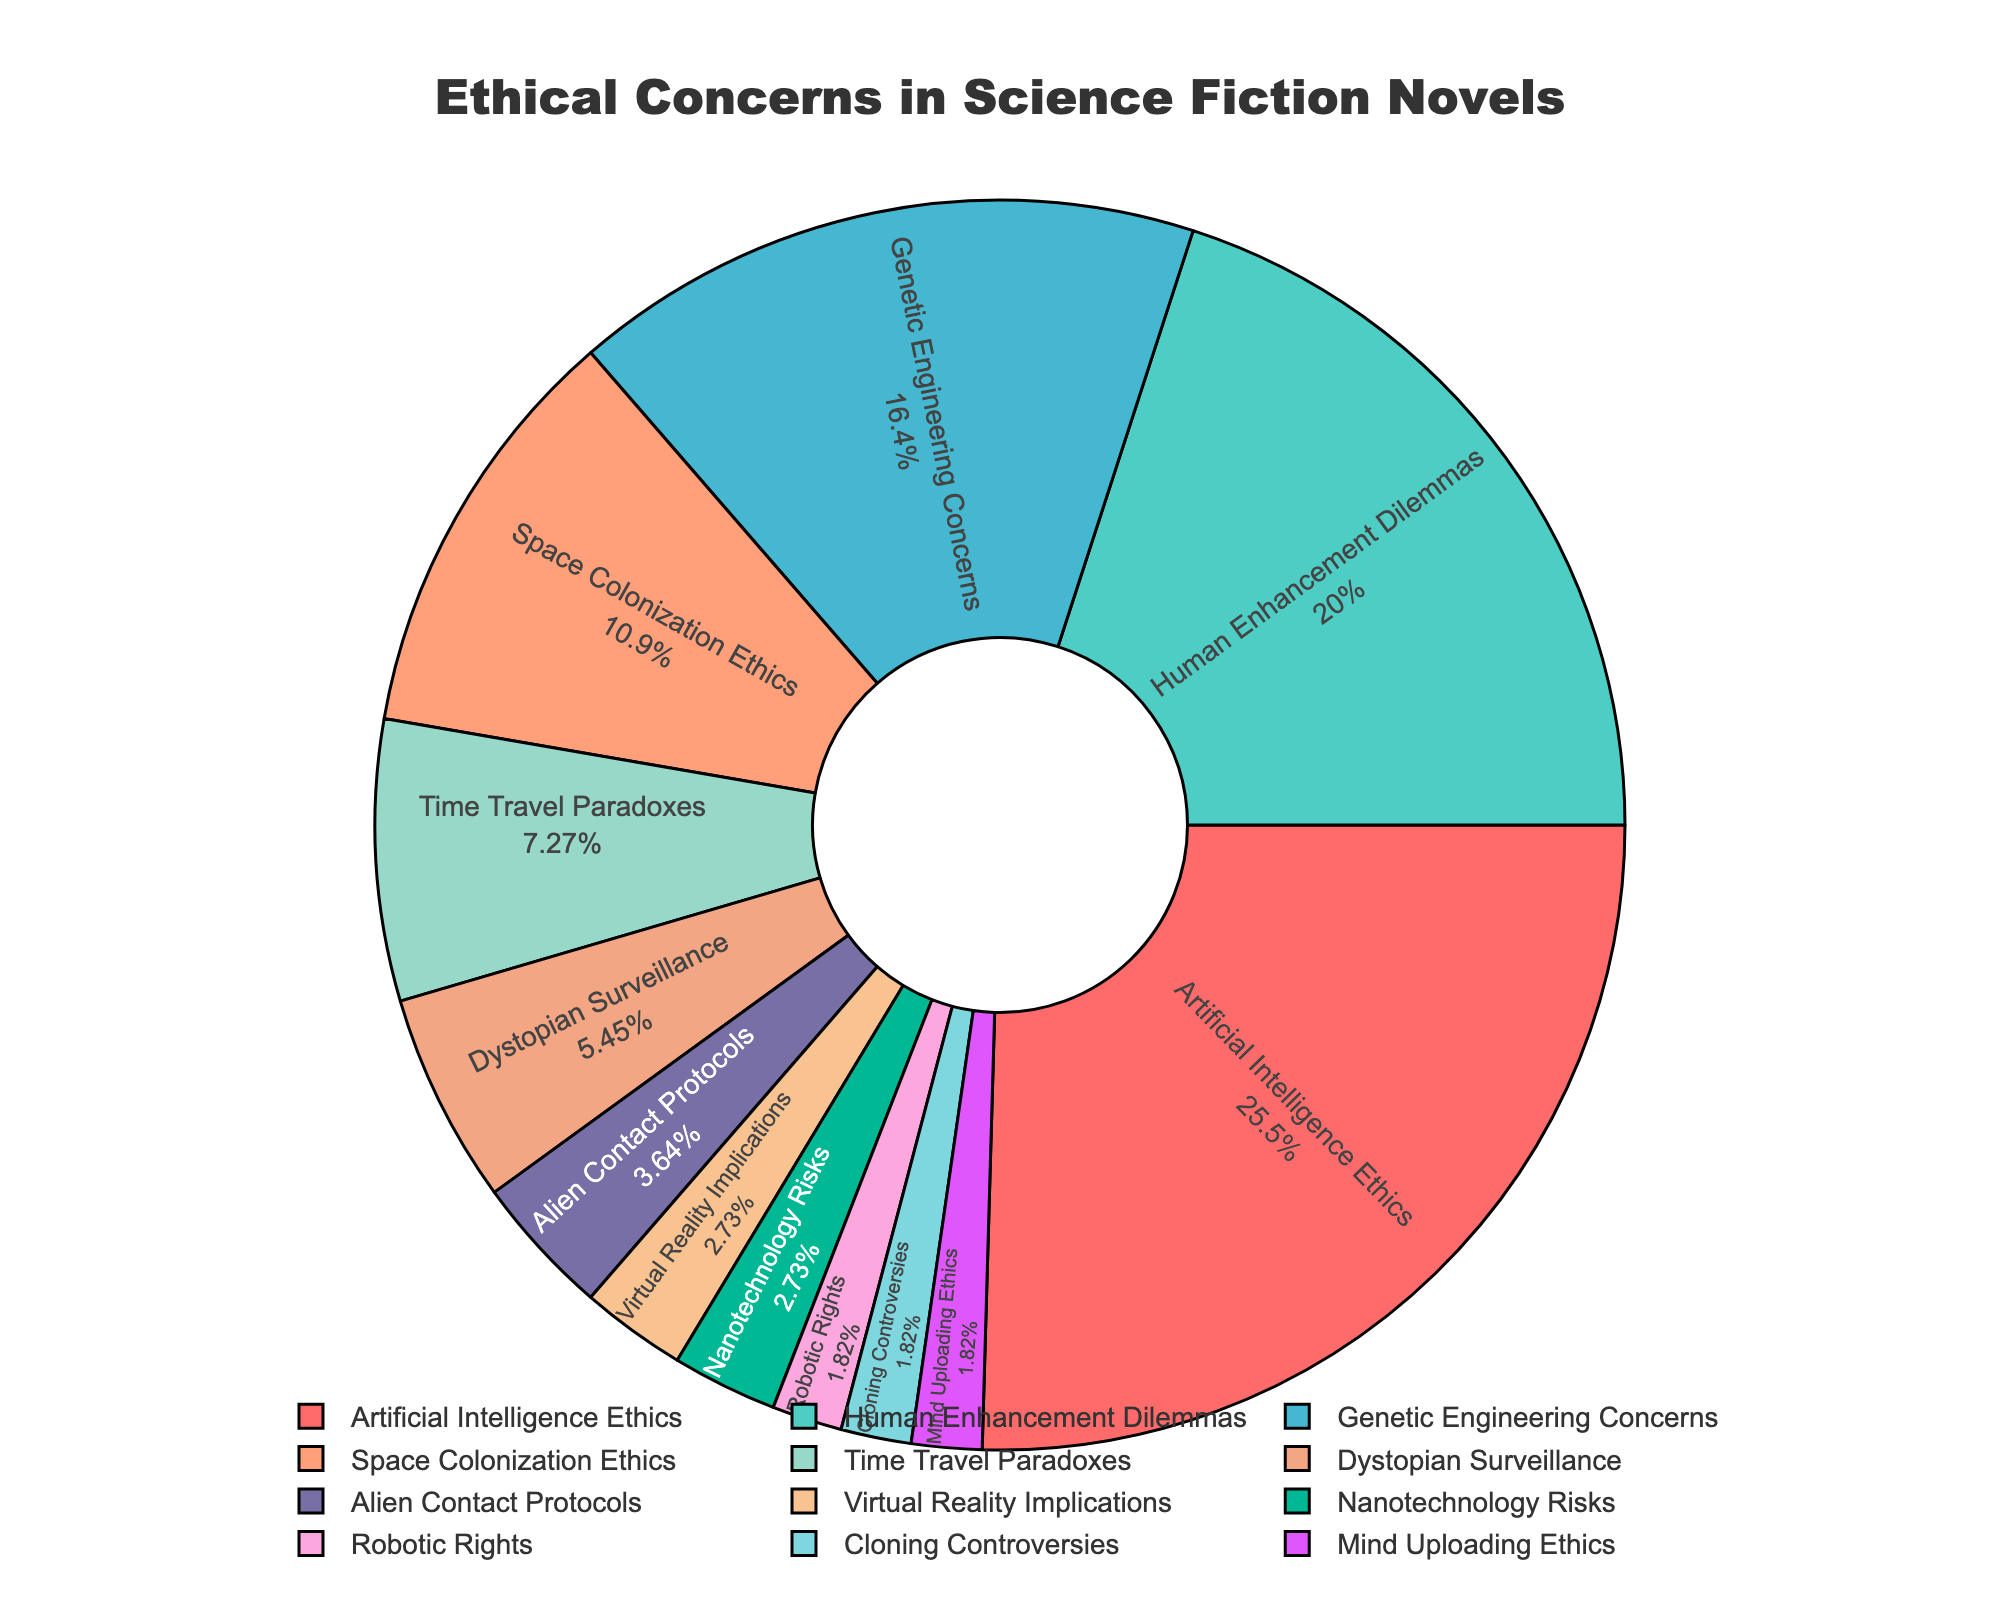Which category has the largest percentage of ethical concerns? By examining the chart, the largest segment is labeled "Artificial Intelligence Ethics" with a percentage of 28%.
Answer: Artificial Intelligence Ethics Which category has the smallest percentage of ethical concerns? By examining the chart, the smallest segments are labeled "Robotic Rights," "Cloning Controversies," and "Mind Uploading Ethics," each with a percentage of 2%.
Answer: Robotic Rights, Cloning Controversies, Mind Uploading Ethics What is the combined percentage of ethical concerns for "Human Enhancement Dilemmas" and "Genetic Engineering Concerns"? Adding the percentages of "Human Enhancement Dilemmas" (22%) and "Genetic Engineering Concerns" (18%) yields 22% + 18% = 40%.
Answer: 40% How does the percentage of "Space Colonization Ethics" compare to "Time Travel Paradoxes"? "Space Colonization Ethics" has a percentage of 12%, while "Time Travel Paradoxes" has a percentage of 8%. Hence, "Space Colonization Ethics" has a higher percentage.
Answer: Space Colonization Ethics > Time Travel Paradoxes What is the percentage difference between "Dystopian Surveillance" and "Virtual Reality Implications"? "Dystopian Surveillance" has 6%, while "Virtual Reality Implications" has 3%. The difference is 6% - 3% = 3%.
Answer: 3% Which color is associated with the largest segment, and what is the ethical concern? The largest segment, representing "Artificial Intelligence Ethics," is colored red as per the color palette described.
Answer: Red, Artificial Intelligence Ethics What is the total percentage of all categories related to robotics (including "Artificial Intelligence Ethics" and "Robotic Rights")? The percentages are 28% for "Artificial Intelligence Ethics" and 2% for "Robotic Rights". Adding them gives 28% + 2% = 30%.
Answer: 30% How many categories have a percentage of 10% or higher? Categories with 10% or higher are "Artificial Intelligence Ethics" (28%), "Human Enhancement Dilemmas" (22%), "Genetic Engineering Concerns" (18%), and "Space Colonization Ethics" (12%). There are 4 such categories.
Answer: 4 Does the category "Nanotechnology Risks" have a higher or lower percentage than "Alien Contact Protocols"? "Nanotechnology Risks" has 3%, while "Alien Contact Protocols" has 4%. Therefore, "Nanotechnology Risks" has a lower percentage.
Answer: Lower What is the average percentage of the top 3 largest categories? The top three largest categories are "Artificial Intelligence Ethics" (28%), "Human Enhancement Dilemmas" (22%), and "Genetic Engineering Concerns" (18%). The average is (28% + 22% + 18%) / 3 = 22.67%.
Answer: 22.67% 